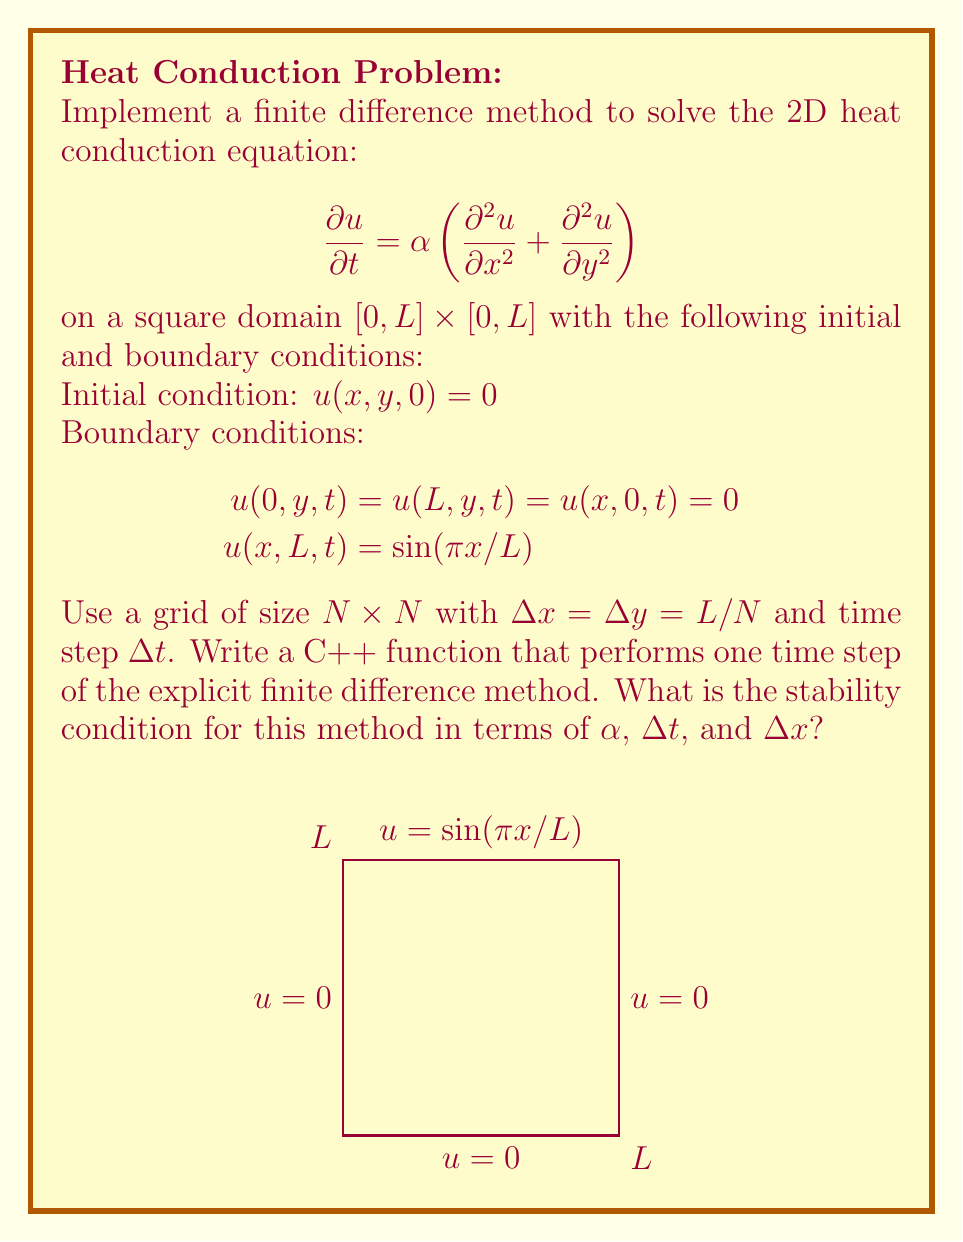Can you solve this math problem? To implement the finite difference method for this 2D heat conduction problem, we need to follow these steps:

1. Discretize the domain into a grid of size $N \times N$.
2. Apply the explicit finite difference scheme to approximate the partial derivatives.
3. Implement the update formula for each interior grid point.
4. Apply the boundary conditions.

Let's break down the process:

1. Discretization:
   - Spatial step: $\Delta x = \Delta y = L / N$
   - Time step: $\Delta t$
   - Grid points: $(i\Delta x, j\Delta y)$ for $i, j = 0, 1, ..., N$

2. Finite difference approximations:
   $$\frac{\partial u}{\partial t} \approx \frac{u_{i,j}^{n+1} - u_{i,j}^n}{\Delta t}$$
   $$\frac{\partial^2 u}{\partial x^2} \approx \frac{u_{i+1,j}^n - 2u_{i,j}^n + u_{i-1,j}^n}{(\Delta x)^2}$$
   $$\frac{\partial^2 u}{\partial y^2} \approx \frac{u_{i,j+1}^n - 2u_{i,j}^n + u_{i,j-1}^n}{(\Delta y)^2}$$

3. Update formula:
   $$u_{i,j}^{n+1} = u_{i,j}^n + \alpha \Delta t \left(\frac{u_{i+1,j}^n - 2u_{i,j}^n + u_{i-1,j}^n}{(\Delta x)^2} + \frac{u_{i,j+1}^n - 2u_{i,j}^n + u_{i,j-1}^n}{(\Delta y)^2}\right)$$

4. C++ function for one time step:

```cpp
void update_step(vector<vector<double>>& u, double alpha, double dt, double dx) {
    int N = u.size() - 1;
    double r = alpha * dt / (dx * dx);
    vector<vector<double>> u_new = u;

    for (int i = 1; i < N; ++i) {
        for (int j = 1; j < N; ++j) {
            u_new[i][j] = u[i][j] + r * (u[i+1][j] + u[i-1][j] + u[i][j+1] + u[i][j-1] - 4*u[i][j]);
        }
    }

    // Apply boundary conditions
    for (int i = 0; i <= N; ++i) {
        u_new[i][0] = u_new[0][i] = u_new[N][i] = 0;
        u_new[i][N] = sin(M_PI * i * dx / L);
    }

    u = u_new;
}
```

5. Stability condition:
   The explicit method is conditionally stable. To ensure stability, we need:

   $$r = \frac{\alpha \Delta t}{(\Delta x)^2} \leq \frac{1}{4}$$

   This is known as the CFL (Courant-Friedrichs-Lewy) condition for the 2D heat equation.
Answer: $\alpha \Delta t \leq \frac{(\Delta x)^2}{4}$ 